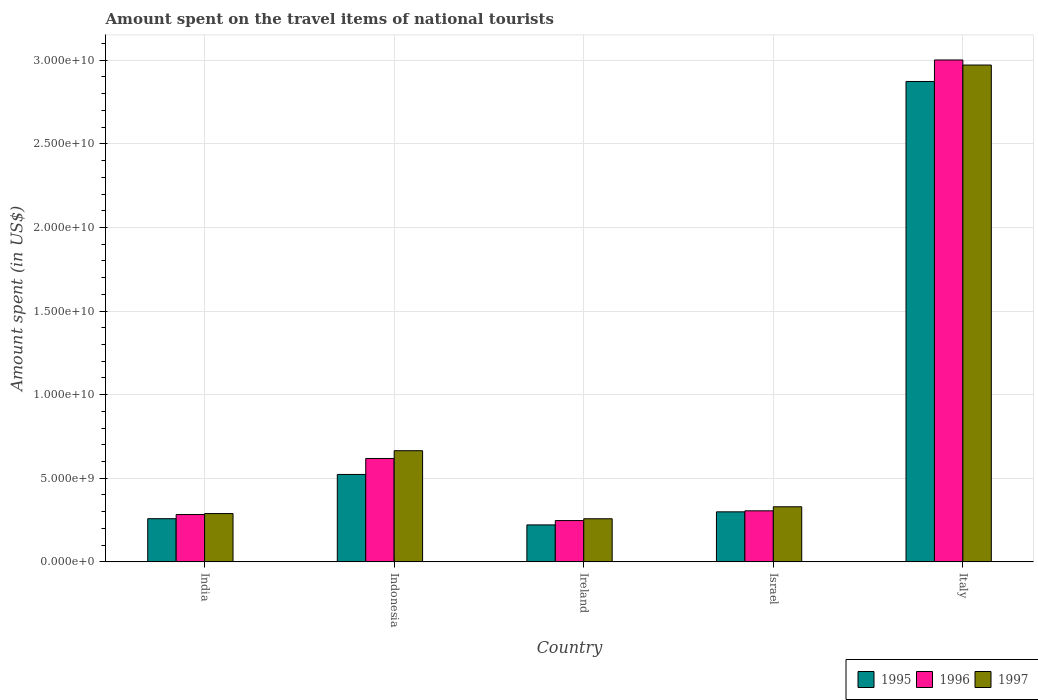Are the number of bars on each tick of the X-axis equal?
Give a very brief answer. Yes. How many bars are there on the 5th tick from the left?
Keep it short and to the point. 3. What is the label of the 1st group of bars from the left?
Make the answer very short. India. What is the amount spent on the travel items of national tourists in 1995 in Ireland?
Make the answer very short. 2.21e+09. Across all countries, what is the maximum amount spent on the travel items of national tourists in 1996?
Make the answer very short. 3.00e+1. Across all countries, what is the minimum amount spent on the travel items of national tourists in 1997?
Your response must be concise. 2.58e+09. In which country was the amount spent on the travel items of national tourists in 1996 maximum?
Offer a terse response. Italy. In which country was the amount spent on the travel items of national tourists in 1995 minimum?
Offer a terse response. Ireland. What is the total amount spent on the travel items of national tourists in 1995 in the graph?
Keep it short and to the point. 4.17e+1. What is the difference between the amount spent on the travel items of national tourists in 1996 in India and that in Israel?
Your response must be concise. -2.22e+08. What is the difference between the amount spent on the travel items of national tourists in 1995 in Ireland and the amount spent on the travel items of national tourists in 1996 in Indonesia?
Ensure brevity in your answer.  -3.97e+09. What is the average amount spent on the travel items of national tourists in 1995 per country?
Offer a very short reply. 8.35e+09. What is the difference between the amount spent on the travel items of national tourists of/in 1995 and amount spent on the travel items of national tourists of/in 1996 in Italy?
Provide a short and direct response. -1.29e+09. In how many countries, is the amount spent on the travel items of national tourists in 1995 greater than 5000000000 US$?
Provide a succinct answer. 2. What is the ratio of the amount spent on the travel items of national tourists in 1995 in Israel to that in Italy?
Provide a short and direct response. 0.1. What is the difference between the highest and the second highest amount spent on the travel items of national tourists in 1996?
Provide a succinct answer. 2.38e+1. What is the difference between the highest and the lowest amount spent on the travel items of national tourists in 1996?
Give a very brief answer. 2.75e+1. What does the 2nd bar from the left in Israel represents?
Your answer should be compact. 1996. Is it the case that in every country, the sum of the amount spent on the travel items of national tourists in 1995 and amount spent on the travel items of national tourists in 1996 is greater than the amount spent on the travel items of national tourists in 1997?
Offer a very short reply. Yes. Are all the bars in the graph horizontal?
Ensure brevity in your answer.  No. Are the values on the major ticks of Y-axis written in scientific E-notation?
Your response must be concise. Yes. Does the graph contain grids?
Your answer should be compact. Yes. What is the title of the graph?
Your answer should be compact. Amount spent on the travel items of national tourists. What is the label or title of the Y-axis?
Provide a short and direct response. Amount spent (in US$). What is the Amount spent (in US$) of 1995 in India?
Offer a terse response. 2.58e+09. What is the Amount spent (in US$) in 1996 in India?
Your response must be concise. 2.83e+09. What is the Amount spent (in US$) in 1997 in India?
Provide a succinct answer. 2.89e+09. What is the Amount spent (in US$) in 1995 in Indonesia?
Provide a short and direct response. 5.23e+09. What is the Amount spent (in US$) of 1996 in Indonesia?
Keep it short and to the point. 6.18e+09. What is the Amount spent (in US$) in 1997 in Indonesia?
Provide a succinct answer. 6.65e+09. What is the Amount spent (in US$) of 1995 in Ireland?
Offer a terse response. 2.21e+09. What is the Amount spent (in US$) of 1996 in Ireland?
Offer a terse response. 2.47e+09. What is the Amount spent (in US$) in 1997 in Ireland?
Your response must be concise. 2.58e+09. What is the Amount spent (in US$) of 1995 in Israel?
Provide a short and direct response. 2.99e+09. What is the Amount spent (in US$) in 1996 in Israel?
Your answer should be compact. 3.05e+09. What is the Amount spent (in US$) of 1997 in Israel?
Offer a terse response. 3.30e+09. What is the Amount spent (in US$) of 1995 in Italy?
Your answer should be very brief. 2.87e+1. What is the Amount spent (in US$) in 1996 in Italy?
Keep it short and to the point. 3.00e+1. What is the Amount spent (in US$) in 1997 in Italy?
Give a very brief answer. 2.97e+1. Across all countries, what is the maximum Amount spent (in US$) in 1995?
Keep it short and to the point. 2.87e+1. Across all countries, what is the maximum Amount spent (in US$) of 1996?
Provide a succinct answer. 3.00e+1. Across all countries, what is the maximum Amount spent (in US$) in 1997?
Give a very brief answer. 2.97e+1. Across all countries, what is the minimum Amount spent (in US$) of 1995?
Make the answer very short. 2.21e+09. Across all countries, what is the minimum Amount spent (in US$) of 1996?
Provide a short and direct response. 2.47e+09. Across all countries, what is the minimum Amount spent (in US$) in 1997?
Provide a short and direct response. 2.58e+09. What is the total Amount spent (in US$) in 1995 in the graph?
Provide a short and direct response. 4.17e+1. What is the total Amount spent (in US$) in 1996 in the graph?
Offer a terse response. 4.46e+1. What is the total Amount spent (in US$) of 1997 in the graph?
Offer a very short reply. 4.51e+1. What is the difference between the Amount spent (in US$) in 1995 in India and that in Indonesia?
Your response must be concise. -2.65e+09. What is the difference between the Amount spent (in US$) of 1996 in India and that in Indonesia?
Your response must be concise. -3.35e+09. What is the difference between the Amount spent (in US$) in 1997 in India and that in Indonesia?
Your response must be concise. -3.76e+09. What is the difference between the Amount spent (in US$) of 1995 in India and that in Ireland?
Ensure brevity in your answer.  3.71e+08. What is the difference between the Amount spent (in US$) of 1996 in India and that in Ireland?
Offer a terse response. 3.61e+08. What is the difference between the Amount spent (in US$) of 1997 in India and that in Ireland?
Your answer should be compact. 3.12e+08. What is the difference between the Amount spent (in US$) in 1995 in India and that in Israel?
Provide a succinct answer. -4.11e+08. What is the difference between the Amount spent (in US$) in 1996 in India and that in Israel?
Ensure brevity in your answer.  -2.22e+08. What is the difference between the Amount spent (in US$) of 1997 in India and that in Israel?
Offer a very short reply. -4.05e+08. What is the difference between the Amount spent (in US$) of 1995 in India and that in Italy?
Provide a succinct answer. -2.61e+1. What is the difference between the Amount spent (in US$) of 1996 in India and that in Italy?
Keep it short and to the point. -2.72e+1. What is the difference between the Amount spent (in US$) in 1997 in India and that in Italy?
Provide a short and direct response. -2.68e+1. What is the difference between the Amount spent (in US$) of 1995 in Indonesia and that in Ireland?
Your response must be concise. 3.02e+09. What is the difference between the Amount spent (in US$) in 1996 in Indonesia and that in Ireland?
Provide a short and direct response. 3.71e+09. What is the difference between the Amount spent (in US$) in 1997 in Indonesia and that in Ireland?
Give a very brief answer. 4.07e+09. What is the difference between the Amount spent (in US$) of 1995 in Indonesia and that in Israel?
Ensure brevity in your answer.  2.24e+09. What is the difference between the Amount spent (in US$) of 1996 in Indonesia and that in Israel?
Offer a terse response. 3.13e+09. What is the difference between the Amount spent (in US$) of 1997 in Indonesia and that in Israel?
Provide a succinct answer. 3.35e+09. What is the difference between the Amount spent (in US$) in 1995 in Indonesia and that in Italy?
Make the answer very short. -2.35e+1. What is the difference between the Amount spent (in US$) in 1996 in Indonesia and that in Italy?
Offer a terse response. -2.38e+1. What is the difference between the Amount spent (in US$) in 1997 in Indonesia and that in Italy?
Provide a short and direct response. -2.31e+1. What is the difference between the Amount spent (in US$) in 1995 in Ireland and that in Israel?
Keep it short and to the point. -7.82e+08. What is the difference between the Amount spent (in US$) of 1996 in Ireland and that in Israel?
Offer a terse response. -5.83e+08. What is the difference between the Amount spent (in US$) in 1997 in Ireland and that in Israel?
Provide a short and direct response. -7.17e+08. What is the difference between the Amount spent (in US$) of 1995 in Ireland and that in Italy?
Your answer should be very brief. -2.65e+1. What is the difference between the Amount spent (in US$) of 1996 in Ireland and that in Italy?
Provide a short and direct response. -2.75e+1. What is the difference between the Amount spent (in US$) in 1997 in Ireland and that in Italy?
Your answer should be very brief. -2.71e+1. What is the difference between the Amount spent (in US$) in 1995 in Israel and that in Italy?
Make the answer very short. -2.57e+1. What is the difference between the Amount spent (in US$) of 1996 in Israel and that in Italy?
Your response must be concise. -2.70e+1. What is the difference between the Amount spent (in US$) in 1997 in Israel and that in Italy?
Your answer should be compact. -2.64e+1. What is the difference between the Amount spent (in US$) of 1995 in India and the Amount spent (in US$) of 1996 in Indonesia?
Your response must be concise. -3.60e+09. What is the difference between the Amount spent (in US$) in 1995 in India and the Amount spent (in US$) in 1997 in Indonesia?
Your answer should be compact. -4.07e+09. What is the difference between the Amount spent (in US$) of 1996 in India and the Amount spent (in US$) of 1997 in Indonesia?
Ensure brevity in your answer.  -3.82e+09. What is the difference between the Amount spent (in US$) in 1995 in India and the Amount spent (in US$) in 1996 in Ireland?
Offer a very short reply. 1.12e+08. What is the difference between the Amount spent (in US$) of 1995 in India and the Amount spent (in US$) of 1997 in Ireland?
Provide a succinct answer. 4.00e+06. What is the difference between the Amount spent (in US$) of 1996 in India and the Amount spent (in US$) of 1997 in Ireland?
Give a very brief answer. 2.53e+08. What is the difference between the Amount spent (in US$) of 1995 in India and the Amount spent (in US$) of 1996 in Israel?
Provide a succinct answer. -4.71e+08. What is the difference between the Amount spent (in US$) of 1995 in India and the Amount spent (in US$) of 1997 in Israel?
Ensure brevity in your answer.  -7.13e+08. What is the difference between the Amount spent (in US$) of 1996 in India and the Amount spent (in US$) of 1997 in Israel?
Your response must be concise. -4.64e+08. What is the difference between the Amount spent (in US$) of 1995 in India and the Amount spent (in US$) of 1996 in Italy?
Offer a very short reply. -2.74e+1. What is the difference between the Amount spent (in US$) of 1995 in India and the Amount spent (in US$) of 1997 in Italy?
Your response must be concise. -2.71e+1. What is the difference between the Amount spent (in US$) of 1996 in India and the Amount spent (in US$) of 1997 in Italy?
Give a very brief answer. -2.69e+1. What is the difference between the Amount spent (in US$) in 1995 in Indonesia and the Amount spent (in US$) in 1996 in Ireland?
Give a very brief answer. 2.76e+09. What is the difference between the Amount spent (in US$) in 1995 in Indonesia and the Amount spent (in US$) in 1997 in Ireland?
Ensure brevity in your answer.  2.65e+09. What is the difference between the Amount spent (in US$) of 1996 in Indonesia and the Amount spent (in US$) of 1997 in Ireland?
Offer a very short reply. 3.61e+09. What is the difference between the Amount spent (in US$) in 1995 in Indonesia and the Amount spent (in US$) in 1996 in Israel?
Ensure brevity in your answer.  2.18e+09. What is the difference between the Amount spent (in US$) in 1995 in Indonesia and the Amount spent (in US$) in 1997 in Israel?
Offer a terse response. 1.93e+09. What is the difference between the Amount spent (in US$) of 1996 in Indonesia and the Amount spent (in US$) of 1997 in Israel?
Your answer should be very brief. 2.89e+09. What is the difference between the Amount spent (in US$) of 1995 in Indonesia and the Amount spent (in US$) of 1996 in Italy?
Offer a terse response. -2.48e+1. What is the difference between the Amount spent (in US$) of 1995 in Indonesia and the Amount spent (in US$) of 1997 in Italy?
Keep it short and to the point. -2.45e+1. What is the difference between the Amount spent (in US$) in 1996 in Indonesia and the Amount spent (in US$) in 1997 in Italy?
Ensure brevity in your answer.  -2.35e+1. What is the difference between the Amount spent (in US$) in 1995 in Ireland and the Amount spent (in US$) in 1996 in Israel?
Your answer should be very brief. -8.42e+08. What is the difference between the Amount spent (in US$) of 1995 in Ireland and the Amount spent (in US$) of 1997 in Israel?
Offer a very short reply. -1.08e+09. What is the difference between the Amount spent (in US$) in 1996 in Ireland and the Amount spent (in US$) in 1997 in Israel?
Your response must be concise. -8.25e+08. What is the difference between the Amount spent (in US$) in 1995 in Ireland and the Amount spent (in US$) in 1996 in Italy?
Provide a short and direct response. -2.78e+1. What is the difference between the Amount spent (in US$) of 1995 in Ireland and the Amount spent (in US$) of 1997 in Italy?
Make the answer very short. -2.75e+1. What is the difference between the Amount spent (in US$) in 1996 in Ireland and the Amount spent (in US$) in 1997 in Italy?
Your response must be concise. -2.72e+1. What is the difference between the Amount spent (in US$) in 1995 in Israel and the Amount spent (in US$) in 1996 in Italy?
Ensure brevity in your answer.  -2.70e+1. What is the difference between the Amount spent (in US$) of 1995 in Israel and the Amount spent (in US$) of 1997 in Italy?
Make the answer very short. -2.67e+1. What is the difference between the Amount spent (in US$) of 1996 in Israel and the Amount spent (in US$) of 1997 in Italy?
Provide a short and direct response. -2.67e+1. What is the average Amount spent (in US$) in 1995 per country?
Offer a terse response. 8.35e+09. What is the average Amount spent (in US$) in 1996 per country?
Make the answer very short. 8.91e+09. What is the average Amount spent (in US$) of 1997 per country?
Provide a succinct answer. 9.02e+09. What is the difference between the Amount spent (in US$) of 1995 and Amount spent (in US$) of 1996 in India?
Your response must be concise. -2.49e+08. What is the difference between the Amount spent (in US$) in 1995 and Amount spent (in US$) in 1997 in India?
Offer a very short reply. -3.08e+08. What is the difference between the Amount spent (in US$) of 1996 and Amount spent (in US$) of 1997 in India?
Make the answer very short. -5.90e+07. What is the difference between the Amount spent (in US$) of 1995 and Amount spent (in US$) of 1996 in Indonesia?
Give a very brief answer. -9.55e+08. What is the difference between the Amount spent (in US$) in 1995 and Amount spent (in US$) in 1997 in Indonesia?
Offer a very short reply. -1.42e+09. What is the difference between the Amount spent (in US$) in 1996 and Amount spent (in US$) in 1997 in Indonesia?
Ensure brevity in your answer.  -4.64e+08. What is the difference between the Amount spent (in US$) in 1995 and Amount spent (in US$) in 1996 in Ireland?
Offer a very short reply. -2.59e+08. What is the difference between the Amount spent (in US$) in 1995 and Amount spent (in US$) in 1997 in Ireland?
Ensure brevity in your answer.  -3.67e+08. What is the difference between the Amount spent (in US$) in 1996 and Amount spent (in US$) in 1997 in Ireland?
Your answer should be very brief. -1.08e+08. What is the difference between the Amount spent (in US$) in 1995 and Amount spent (in US$) in 1996 in Israel?
Give a very brief answer. -6.00e+07. What is the difference between the Amount spent (in US$) of 1995 and Amount spent (in US$) of 1997 in Israel?
Keep it short and to the point. -3.02e+08. What is the difference between the Amount spent (in US$) in 1996 and Amount spent (in US$) in 1997 in Israel?
Provide a short and direct response. -2.42e+08. What is the difference between the Amount spent (in US$) of 1995 and Amount spent (in US$) of 1996 in Italy?
Offer a terse response. -1.29e+09. What is the difference between the Amount spent (in US$) in 1995 and Amount spent (in US$) in 1997 in Italy?
Your answer should be compact. -9.83e+08. What is the difference between the Amount spent (in US$) in 1996 and Amount spent (in US$) in 1997 in Italy?
Offer a terse response. 3.03e+08. What is the ratio of the Amount spent (in US$) in 1995 in India to that in Indonesia?
Provide a short and direct response. 0.49. What is the ratio of the Amount spent (in US$) in 1996 in India to that in Indonesia?
Your response must be concise. 0.46. What is the ratio of the Amount spent (in US$) of 1997 in India to that in Indonesia?
Your answer should be very brief. 0.43. What is the ratio of the Amount spent (in US$) of 1995 in India to that in Ireland?
Keep it short and to the point. 1.17. What is the ratio of the Amount spent (in US$) of 1996 in India to that in Ireland?
Provide a succinct answer. 1.15. What is the ratio of the Amount spent (in US$) of 1997 in India to that in Ireland?
Provide a succinct answer. 1.12. What is the ratio of the Amount spent (in US$) of 1995 in India to that in Israel?
Offer a terse response. 0.86. What is the ratio of the Amount spent (in US$) of 1996 in India to that in Israel?
Ensure brevity in your answer.  0.93. What is the ratio of the Amount spent (in US$) in 1997 in India to that in Israel?
Ensure brevity in your answer.  0.88. What is the ratio of the Amount spent (in US$) in 1995 in India to that in Italy?
Provide a short and direct response. 0.09. What is the ratio of the Amount spent (in US$) of 1996 in India to that in Italy?
Your answer should be very brief. 0.09. What is the ratio of the Amount spent (in US$) of 1997 in India to that in Italy?
Your answer should be very brief. 0.1. What is the ratio of the Amount spent (in US$) in 1995 in Indonesia to that in Ireland?
Your answer should be compact. 2.37. What is the ratio of the Amount spent (in US$) of 1996 in Indonesia to that in Ireland?
Your response must be concise. 2.5. What is the ratio of the Amount spent (in US$) of 1997 in Indonesia to that in Ireland?
Give a very brief answer. 2.58. What is the ratio of the Amount spent (in US$) of 1995 in Indonesia to that in Israel?
Make the answer very short. 1.75. What is the ratio of the Amount spent (in US$) of 1996 in Indonesia to that in Israel?
Provide a succinct answer. 2.03. What is the ratio of the Amount spent (in US$) of 1997 in Indonesia to that in Israel?
Make the answer very short. 2.02. What is the ratio of the Amount spent (in US$) in 1995 in Indonesia to that in Italy?
Make the answer very short. 0.18. What is the ratio of the Amount spent (in US$) of 1996 in Indonesia to that in Italy?
Offer a terse response. 0.21. What is the ratio of the Amount spent (in US$) of 1997 in Indonesia to that in Italy?
Your answer should be very brief. 0.22. What is the ratio of the Amount spent (in US$) of 1995 in Ireland to that in Israel?
Your answer should be compact. 0.74. What is the ratio of the Amount spent (in US$) of 1996 in Ireland to that in Israel?
Your answer should be compact. 0.81. What is the ratio of the Amount spent (in US$) in 1997 in Ireland to that in Israel?
Your response must be concise. 0.78. What is the ratio of the Amount spent (in US$) in 1995 in Ireland to that in Italy?
Offer a terse response. 0.08. What is the ratio of the Amount spent (in US$) in 1996 in Ireland to that in Italy?
Offer a terse response. 0.08. What is the ratio of the Amount spent (in US$) in 1997 in Ireland to that in Italy?
Make the answer very short. 0.09. What is the ratio of the Amount spent (in US$) of 1995 in Israel to that in Italy?
Provide a short and direct response. 0.1. What is the ratio of the Amount spent (in US$) in 1996 in Israel to that in Italy?
Give a very brief answer. 0.1. What is the ratio of the Amount spent (in US$) of 1997 in Israel to that in Italy?
Make the answer very short. 0.11. What is the difference between the highest and the second highest Amount spent (in US$) of 1995?
Your answer should be compact. 2.35e+1. What is the difference between the highest and the second highest Amount spent (in US$) in 1996?
Provide a succinct answer. 2.38e+1. What is the difference between the highest and the second highest Amount spent (in US$) in 1997?
Give a very brief answer. 2.31e+1. What is the difference between the highest and the lowest Amount spent (in US$) in 1995?
Ensure brevity in your answer.  2.65e+1. What is the difference between the highest and the lowest Amount spent (in US$) of 1996?
Ensure brevity in your answer.  2.75e+1. What is the difference between the highest and the lowest Amount spent (in US$) in 1997?
Provide a succinct answer. 2.71e+1. 